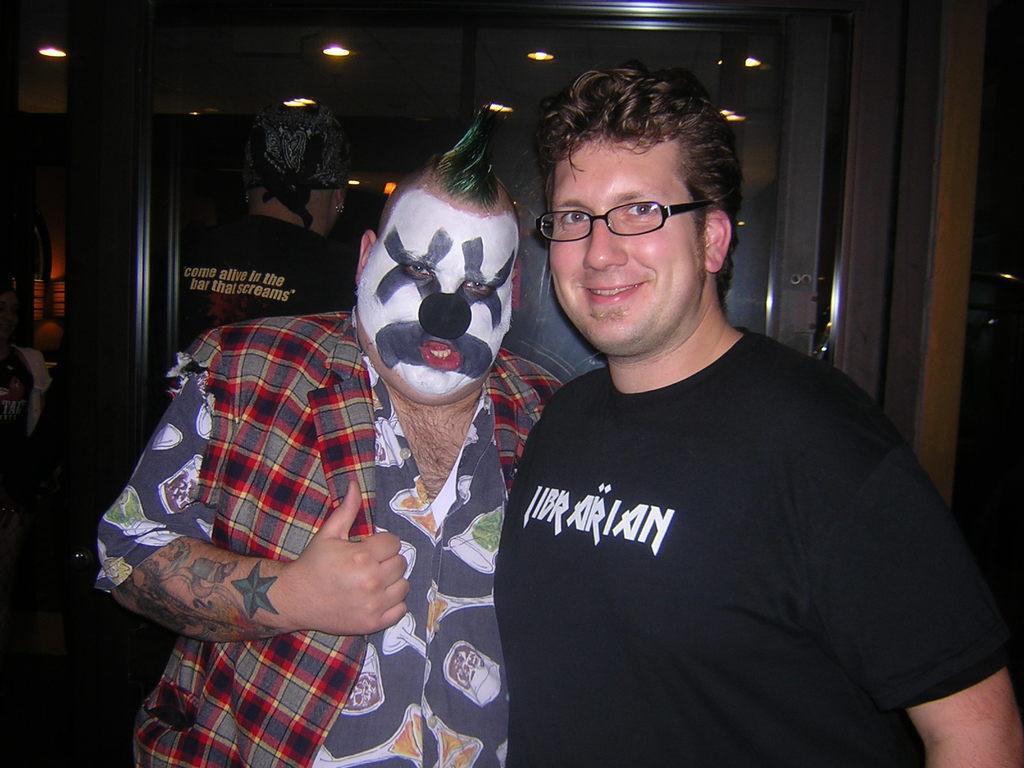Describe this image in one or two sentences. There are two people standing and this man smiling and wore black t shirt and spectacle. In the background we can see lights,board and it is dark. 